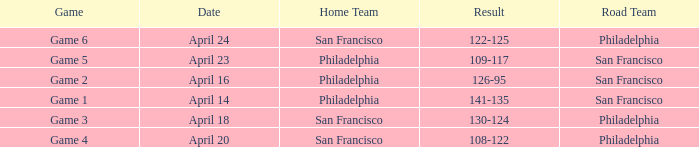Can you give me this table as a dict? {'header': ['Game', 'Date', 'Home Team', 'Result', 'Road Team'], 'rows': [['Game 6', 'April 24', 'San Francisco', '122-125', 'Philadelphia'], ['Game 5', 'April 23', 'Philadelphia', '109-117', 'San Francisco'], ['Game 2', 'April 16', 'Philadelphia', '126-95', 'San Francisco'], ['Game 1', 'April 14', 'Philadelphia', '141-135', 'San Francisco'], ['Game 3', 'April 18', 'San Francisco', '130-124', 'Philadelphia'], ['Game 4', 'April 20', 'San Francisco', '108-122', 'Philadelphia']]} Which games had Philadelphia as home team? Game 1, Game 2, Game 5. 